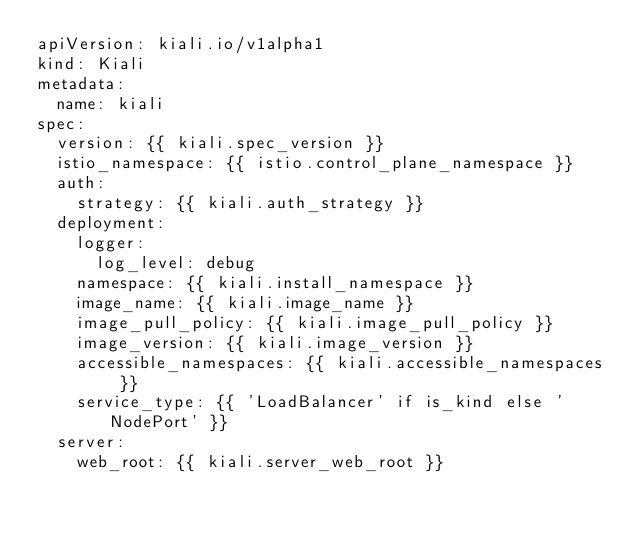<code> <loc_0><loc_0><loc_500><loc_500><_YAML_>apiVersion: kiali.io/v1alpha1
kind: Kiali
metadata:
  name: kiali
spec:
  version: {{ kiali.spec_version }}
  istio_namespace: {{ istio.control_plane_namespace }}
  auth:
    strategy: {{ kiali.auth_strategy }}
  deployment:
    logger:
      log_level: debug
    namespace: {{ kiali.install_namespace }}
    image_name: {{ kiali.image_name }}
    image_pull_policy: {{ kiali.image_pull_policy }}
    image_version: {{ kiali.image_version }}
    accessible_namespaces: {{ kiali.accessible_namespaces }}
    service_type: {{ 'LoadBalancer' if is_kind else 'NodePort' }}
  server:
    web_root: {{ kiali.server_web_root }}
</code> 